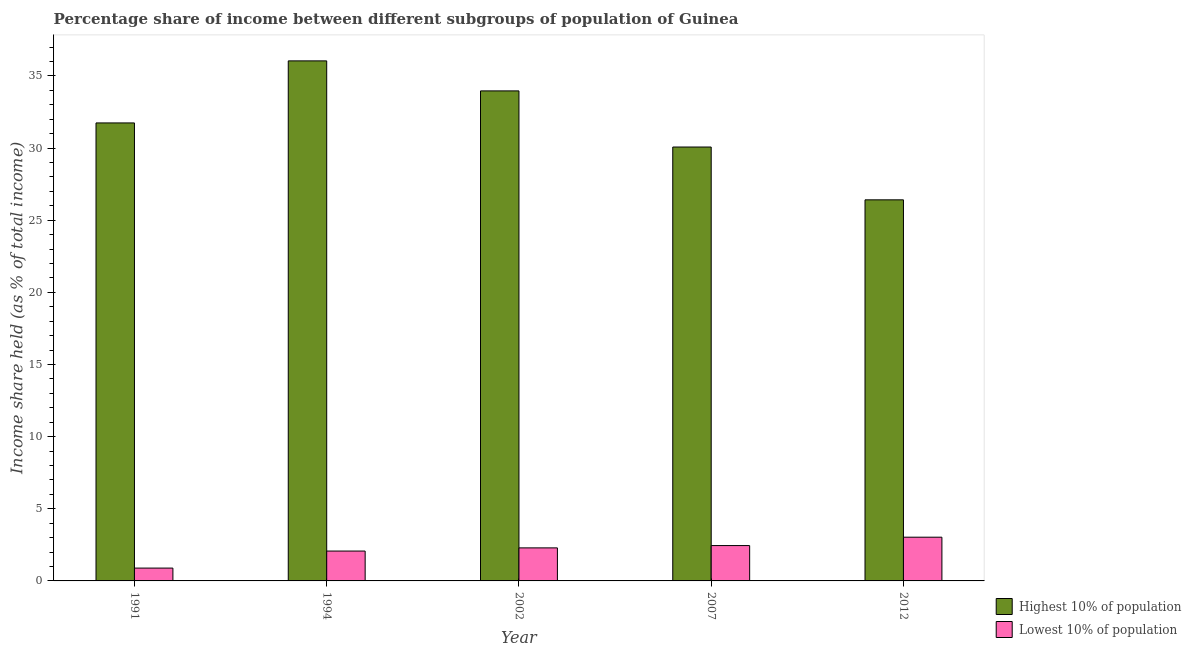How many groups of bars are there?
Ensure brevity in your answer.  5. Are the number of bars per tick equal to the number of legend labels?
Your response must be concise. Yes. What is the label of the 5th group of bars from the left?
Offer a very short reply. 2012. What is the income share held by lowest 10% of the population in 2002?
Your answer should be very brief. 2.29. Across all years, what is the maximum income share held by lowest 10% of the population?
Your answer should be very brief. 3.03. Across all years, what is the minimum income share held by highest 10% of the population?
Keep it short and to the point. 26.41. In which year was the income share held by highest 10% of the population minimum?
Provide a succinct answer. 2012. What is the total income share held by lowest 10% of the population in the graph?
Provide a short and direct response. 10.73. What is the difference between the income share held by lowest 10% of the population in 1991 and that in 2007?
Your answer should be compact. -1.56. What is the difference between the income share held by lowest 10% of the population in 1994 and the income share held by highest 10% of the population in 1991?
Provide a short and direct response. 1.18. What is the average income share held by highest 10% of the population per year?
Give a very brief answer. 31.64. In the year 2002, what is the difference between the income share held by highest 10% of the population and income share held by lowest 10% of the population?
Ensure brevity in your answer.  0. In how many years, is the income share held by lowest 10% of the population greater than 15 %?
Your answer should be compact. 0. What is the ratio of the income share held by lowest 10% of the population in 1994 to that in 2007?
Your answer should be very brief. 0.84. Is the income share held by highest 10% of the population in 1994 less than that in 2002?
Provide a succinct answer. No. Is the difference between the income share held by highest 10% of the population in 1994 and 2002 greater than the difference between the income share held by lowest 10% of the population in 1994 and 2002?
Give a very brief answer. No. What is the difference between the highest and the second highest income share held by highest 10% of the population?
Your answer should be compact. 2.08. What is the difference between the highest and the lowest income share held by lowest 10% of the population?
Your answer should be compact. 2.14. Is the sum of the income share held by highest 10% of the population in 1991 and 2007 greater than the maximum income share held by lowest 10% of the population across all years?
Your answer should be very brief. Yes. What does the 1st bar from the left in 2012 represents?
Make the answer very short. Highest 10% of population. What does the 1st bar from the right in 2002 represents?
Your response must be concise. Lowest 10% of population. How many bars are there?
Your answer should be very brief. 10. How many years are there in the graph?
Provide a short and direct response. 5. What is the difference between two consecutive major ticks on the Y-axis?
Provide a short and direct response. 5. Are the values on the major ticks of Y-axis written in scientific E-notation?
Keep it short and to the point. No. Does the graph contain any zero values?
Offer a terse response. No. Does the graph contain grids?
Keep it short and to the point. No. What is the title of the graph?
Your answer should be very brief. Percentage share of income between different subgroups of population of Guinea. What is the label or title of the X-axis?
Ensure brevity in your answer.  Year. What is the label or title of the Y-axis?
Your answer should be compact. Income share held (as % of total income). What is the Income share held (as % of total income) of Highest 10% of population in 1991?
Provide a succinct answer. 31.74. What is the Income share held (as % of total income) of Lowest 10% of population in 1991?
Keep it short and to the point. 0.89. What is the Income share held (as % of total income) in Highest 10% of population in 1994?
Provide a short and direct response. 36.04. What is the Income share held (as % of total income) of Lowest 10% of population in 1994?
Your answer should be compact. 2.07. What is the Income share held (as % of total income) in Highest 10% of population in 2002?
Your answer should be compact. 33.96. What is the Income share held (as % of total income) in Lowest 10% of population in 2002?
Your answer should be compact. 2.29. What is the Income share held (as % of total income) in Highest 10% of population in 2007?
Your response must be concise. 30.07. What is the Income share held (as % of total income) in Lowest 10% of population in 2007?
Your answer should be very brief. 2.45. What is the Income share held (as % of total income) of Highest 10% of population in 2012?
Your answer should be very brief. 26.41. What is the Income share held (as % of total income) of Lowest 10% of population in 2012?
Your answer should be very brief. 3.03. Across all years, what is the maximum Income share held (as % of total income) in Highest 10% of population?
Your answer should be very brief. 36.04. Across all years, what is the maximum Income share held (as % of total income) in Lowest 10% of population?
Keep it short and to the point. 3.03. Across all years, what is the minimum Income share held (as % of total income) in Highest 10% of population?
Offer a terse response. 26.41. Across all years, what is the minimum Income share held (as % of total income) in Lowest 10% of population?
Your response must be concise. 0.89. What is the total Income share held (as % of total income) of Highest 10% of population in the graph?
Your answer should be compact. 158.22. What is the total Income share held (as % of total income) of Lowest 10% of population in the graph?
Make the answer very short. 10.73. What is the difference between the Income share held (as % of total income) of Lowest 10% of population in 1991 and that in 1994?
Your answer should be compact. -1.18. What is the difference between the Income share held (as % of total income) in Highest 10% of population in 1991 and that in 2002?
Offer a very short reply. -2.22. What is the difference between the Income share held (as % of total income) of Lowest 10% of population in 1991 and that in 2002?
Keep it short and to the point. -1.4. What is the difference between the Income share held (as % of total income) in Highest 10% of population in 1991 and that in 2007?
Your answer should be very brief. 1.67. What is the difference between the Income share held (as % of total income) in Lowest 10% of population in 1991 and that in 2007?
Ensure brevity in your answer.  -1.56. What is the difference between the Income share held (as % of total income) in Highest 10% of population in 1991 and that in 2012?
Make the answer very short. 5.33. What is the difference between the Income share held (as % of total income) of Lowest 10% of population in 1991 and that in 2012?
Your answer should be very brief. -2.14. What is the difference between the Income share held (as % of total income) in Highest 10% of population in 1994 and that in 2002?
Offer a very short reply. 2.08. What is the difference between the Income share held (as % of total income) of Lowest 10% of population in 1994 and that in 2002?
Provide a succinct answer. -0.22. What is the difference between the Income share held (as % of total income) of Highest 10% of population in 1994 and that in 2007?
Provide a short and direct response. 5.97. What is the difference between the Income share held (as % of total income) of Lowest 10% of population in 1994 and that in 2007?
Ensure brevity in your answer.  -0.38. What is the difference between the Income share held (as % of total income) of Highest 10% of population in 1994 and that in 2012?
Your answer should be compact. 9.63. What is the difference between the Income share held (as % of total income) in Lowest 10% of population in 1994 and that in 2012?
Provide a succinct answer. -0.96. What is the difference between the Income share held (as % of total income) of Highest 10% of population in 2002 and that in 2007?
Your answer should be very brief. 3.89. What is the difference between the Income share held (as % of total income) in Lowest 10% of population in 2002 and that in 2007?
Give a very brief answer. -0.16. What is the difference between the Income share held (as % of total income) of Highest 10% of population in 2002 and that in 2012?
Make the answer very short. 7.55. What is the difference between the Income share held (as % of total income) in Lowest 10% of population in 2002 and that in 2012?
Offer a very short reply. -0.74. What is the difference between the Income share held (as % of total income) of Highest 10% of population in 2007 and that in 2012?
Provide a short and direct response. 3.66. What is the difference between the Income share held (as % of total income) in Lowest 10% of population in 2007 and that in 2012?
Ensure brevity in your answer.  -0.58. What is the difference between the Income share held (as % of total income) of Highest 10% of population in 1991 and the Income share held (as % of total income) of Lowest 10% of population in 1994?
Your answer should be very brief. 29.67. What is the difference between the Income share held (as % of total income) in Highest 10% of population in 1991 and the Income share held (as % of total income) in Lowest 10% of population in 2002?
Provide a short and direct response. 29.45. What is the difference between the Income share held (as % of total income) in Highest 10% of population in 1991 and the Income share held (as % of total income) in Lowest 10% of population in 2007?
Offer a terse response. 29.29. What is the difference between the Income share held (as % of total income) in Highest 10% of population in 1991 and the Income share held (as % of total income) in Lowest 10% of population in 2012?
Ensure brevity in your answer.  28.71. What is the difference between the Income share held (as % of total income) of Highest 10% of population in 1994 and the Income share held (as % of total income) of Lowest 10% of population in 2002?
Your answer should be very brief. 33.75. What is the difference between the Income share held (as % of total income) in Highest 10% of population in 1994 and the Income share held (as % of total income) in Lowest 10% of population in 2007?
Keep it short and to the point. 33.59. What is the difference between the Income share held (as % of total income) in Highest 10% of population in 1994 and the Income share held (as % of total income) in Lowest 10% of population in 2012?
Your response must be concise. 33.01. What is the difference between the Income share held (as % of total income) in Highest 10% of population in 2002 and the Income share held (as % of total income) in Lowest 10% of population in 2007?
Offer a terse response. 31.51. What is the difference between the Income share held (as % of total income) in Highest 10% of population in 2002 and the Income share held (as % of total income) in Lowest 10% of population in 2012?
Your answer should be very brief. 30.93. What is the difference between the Income share held (as % of total income) of Highest 10% of population in 2007 and the Income share held (as % of total income) of Lowest 10% of population in 2012?
Give a very brief answer. 27.04. What is the average Income share held (as % of total income) in Highest 10% of population per year?
Your answer should be compact. 31.64. What is the average Income share held (as % of total income) of Lowest 10% of population per year?
Ensure brevity in your answer.  2.15. In the year 1991, what is the difference between the Income share held (as % of total income) of Highest 10% of population and Income share held (as % of total income) of Lowest 10% of population?
Offer a very short reply. 30.85. In the year 1994, what is the difference between the Income share held (as % of total income) of Highest 10% of population and Income share held (as % of total income) of Lowest 10% of population?
Offer a very short reply. 33.97. In the year 2002, what is the difference between the Income share held (as % of total income) in Highest 10% of population and Income share held (as % of total income) in Lowest 10% of population?
Provide a succinct answer. 31.67. In the year 2007, what is the difference between the Income share held (as % of total income) in Highest 10% of population and Income share held (as % of total income) in Lowest 10% of population?
Ensure brevity in your answer.  27.62. In the year 2012, what is the difference between the Income share held (as % of total income) of Highest 10% of population and Income share held (as % of total income) of Lowest 10% of population?
Your answer should be very brief. 23.38. What is the ratio of the Income share held (as % of total income) in Highest 10% of population in 1991 to that in 1994?
Ensure brevity in your answer.  0.88. What is the ratio of the Income share held (as % of total income) in Lowest 10% of population in 1991 to that in 1994?
Offer a terse response. 0.43. What is the ratio of the Income share held (as % of total income) in Highest 10% of population in 1991 to that in 2002?
Keep it short and to the point. 0.93. What is the ratio of the Income share held (as % of total income) in Lowest 10% of population in 1991 to that in 2002?
Your answer should be very brief. 0.39. What is the ratio of the Income share held (as % of total income) of Highest 10% of population in 1991 to that in 2007?
Provide a succinct answer. 1.06. What is the ratio of the Income share held (as % of total income) in Lowest 10% of population in 1991 to that in 2007?
Keep it short and to the point. 0.36. What is the ratio of the Income share held (as % of total income) of Highest 10% of population in 1991 to that in 2012?
Your answer should be very brief. 1.2. What is the ratio of the Income share held (as % of total income) of Lowest 10% of population in 1991 to that in 2012?
Your response must be concise. 0.29. What is the ratio of the Income share held (as % of total income) of Highest 10% of population in 1994 to that in 2002?
Your answer should be very brief. 1.06. What is the ratio of the Income share held (as % of total income) of Lowest 10% of population in 1994 to that in 2002?
Your answer should be very brief. 0.9. What is the ratio of the Income share held (as % of total income) in Highest 10% of population in 1994 to that in 2007?
Give a very brief answer. 1.2. What is the ratio of the Income share held (as % of total income) of Lowest 10% of population in 1994 to that in 2007?
Provide a short and direct response. 0.84. What is the ratio of the Income share held (as % of total income) of Highest 10% of population in 1994 to that in 2012?
Your answer should be compact. 1.36. What is the ratio of the Income share held (as % of total income) in Lowest 10% of population in 1994 to that in 2012?
Make the answer very short. 0.68. What is the ratio of the Income share held (as % of total income) of Highest 10% of population in 2002 to that in 2007?
Provide a succinct answer. 1.13. What is the ratio of the Income share held (as % of total income) in Lowest 10% of population in 2002 to that in 2007?
Offer a very short reply. 0.93. What is the ratio of the Income share held (as % of total income) of Highest 10% of population in 2002 to that in 2012?
Your response must be concise. 1.29. What is the ratio of the Income share held (as % of total income) in Lowest 10% of population in 2002 to that in 2012?
Offer a terse response. 0.76. What is the ratio of the Income share held (as % of total income) of Highest 10% of population in 2007 to that in 2012?
Keep it short and to the point. 1.14. What is the ratio of the Income share held (as % of total income) in Lowest 10% of population in 2007 to that in 2012?
Ensure brevity in your answer.  0.81. What is the difference between the highest and the second highest Income share held (as % of total income) of Highest 10% of population?
Ensure brevity in your answer.  2.08. What is the difference between the highest and the second highest Income share held (as % of total income) of Lowest 10% of population?
Give a very brief answer. 0.58. What is the difference between the highest and the lowest Income share held (as % of total income) of Highest 10% of population?
Provide a short and direct response. 9.63. What is the difference between the highest and the lowest Income share held (as % of total income) of Lowest 10% of population?
Provide a short and direct response. 2.14. 